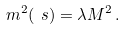<formula> <loc_0><loc_0><loc_500><loc_500>m ^ { 2 } ( \ s ) = \lambda M ^ { 2 } \, .</formula> 